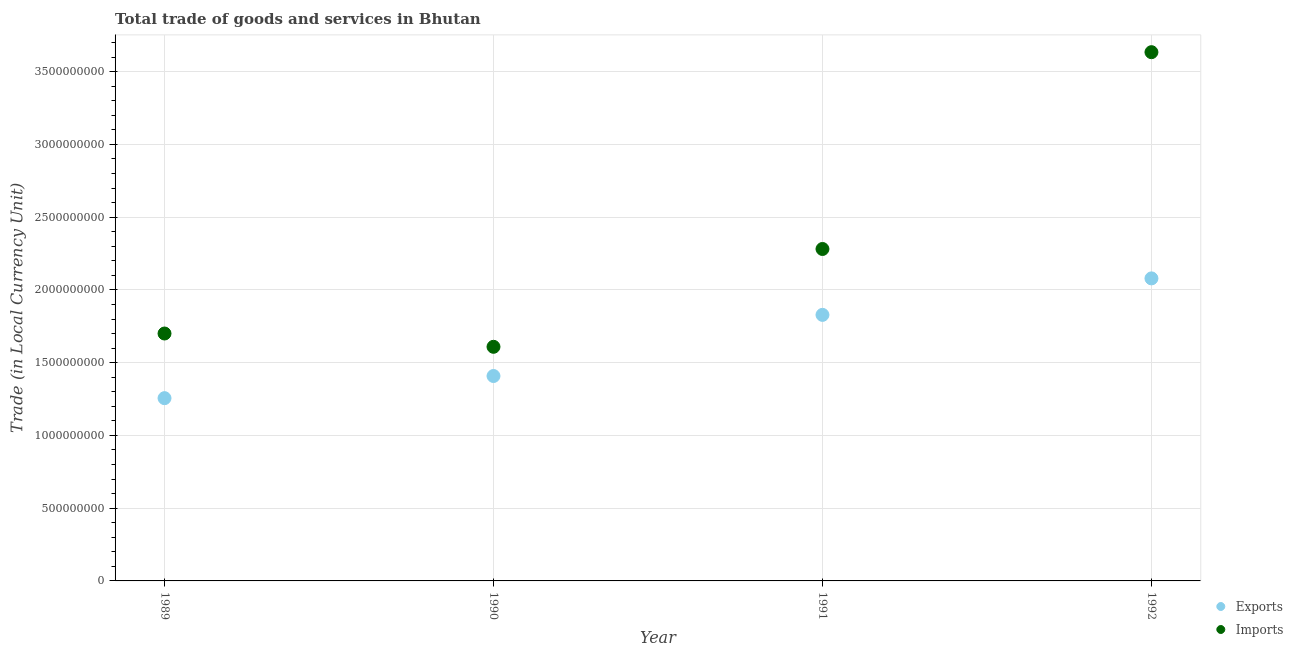Is the number of dotlines equal to the number of legend labels?
Your answer should be very brief. Yes. What is the export of goods and services in 1992?
Offer a terse response. 2.08e+09. Across all years, what is the maximum export of goods and services?
Give a very brief answer. 2.08e+09. Across all years, what is the minimum imports of goods and services?
Make the answer very short. 1.61e+09. In which year was the imports of goods and services maximum?
Your response must be concise. 1992. What is the total export of goods and services in the graph?
Provide a succinct answer. 6.57e+09. What is the difference between the export of goods and services in 1989 and that in 1990?
Keep it short and to the point. -1.52e+08. What is the difference between the export of goods and services in 1991 and the imports of goods and services in 1992?
Give a very brief answer. -1.81e+09. What is the average imports of goods and services per year?
Give a very brief answer. 2.31e+09. In the year 1989, what is the difference between the imports of goods and services and export of goods and services?
Ensure brevity in your answer.  4.44e+08. In how many years, is the imports of goods and services greater than 900000000 LCU?
Your response must be concise. 4. What is the ratio of the imports of goods and services in 1989 to that in 1991?
Offer a very short reply. 0.75. Is the difference between the export of goods and services in 1990 and 1991 greater than the difference between the imports of goods and services in 1990 and 1991?
Your answer should be compact. Yes. What is the difference between the highest and the second highest export of goods and services?
Give a very brief answer. 2.51e+08. What is the difference between the highest and the lowest imports of goods and services?
Offer a terse response. 2.03e+09. Is the sum of the imports of goods and services in 1989 and 1991 greater than the maximum export of goods and services across all years?
Provide a short and direct response. Yes. Is the imports of goods and services strictly less than the export of goods and services over the years?
Ensure brevity in your answer.  No. How many dotlines are there?
Provide a succinct answer. 2. How many years are there in the graph?
Give a very brief answer. 4. What is the difference between two consecutive major ticks on the Y-axis?
Provide a succinct answer. 5.00e+08. Are the values on the major ticks of Y-axis written in scientific E-notation?
Keep it short and to the point. No. Does the graph contain grids?
Provide a succinct answer. Yes. How many legend labels are there?
Your answer should be very brief. 2. What is the title of the graph?
Make the answer very short. Total trade of goods and services in Bhutan. What is the label or title of the X-axis?
Offer a very short reply. Year. What is the label or title of the Y-axis?
Offer a terse response. Trade (in Local Currency Unit). What is the Trade (in Local Currency Unit) of Exports in 1989?
Keep it short and to the point. 1.26e+09. What is the Trade (in Local Currency Unit) of Imports in 1989?
Offer a terse response. 1.70e+09. What is the Trade (in Local Currency Unit) in Exports in 1990?
Offer a very short reply. 1.41e+09. What is the Trade (in Local Currency Unit) of Imports in 1990?
Make the answer very short. 1.61e+09. What is the Trade (in Local Currency Unit) in Exports in 1991?
Your answer should be compact. 1.83e+09. What is the Trade (in Local Currency Unit) of Imports in 1991?
Keep it short and to the point. 2.28e+09. What is the Trade (in Local Currency Unit) in Exports in 1992?
Your answer should be compact. 2.08e+09. What is the Trade (in Local Currency Unit) of Imports in 1992?
Keep it short and to the point. 3.63e+09. Across all years, what is the maximum Trade (in Local Currency Unit) in Exports?
Provide a short and direct response. 2.08e+09. Across all years, what is the maximum Trade (in Local Currency Unit) in Imports?
Your response must be concise. 3.63e+09. Across all years, what is the minimum Trade (in Local Currency Unit) in Exports?
Keep it short and to the point. 1.26e+09. Across all years, what is the minimum Trade (in Local Currency Unit) in Imports?
Provide a succinct answer. 1.61e+09. What is the total Trade (in Local Currency Unit) in Exports in the graph?
Provide a short and direct response. 6.57e+09. What is the total Trade (in Local Currency Unit) of Imports in the graph?
Offer a terse response. 9.22e+09. What is the difference between the Trade (in Local Currency Unit) of Exports in 1989 and that in 1990?
Your response must be concise. -1.52e+08. What is the difference between the Trade (in Local Currency Unit) of Imports in 1989 and that in 1990?
Your answer should be compact. 9.14e+07. What is the difference between the Trade (in Local Currency Unit) in Exports in 1989 and that in 1991?
Your answer should be compact. -5.72e+08. What is the difference between the Trade (in Local Currency Unit) in Imports in 1989 and that in 1991?
Provide a short and direct response. -5.81e+08. What is the difference between the Trade (in Local Currency Unit) of Exports in 1989 and that in 1992?
Keep it short and to the point. -8.23e+08. What is the difference between the Trade (in Local Currency Unit) in Imports in 1989 and that in 1992?
Offer a very short reply. -1.93e+09. What is the difference between the Trade (in Local Currency Unit) in Exports in 1990 and that in 1991?
Keep it short and to the point. -4.20e+08. What is the difference between the Trade (in Local Currency Unit) of Imports in 1990 and that in 1991?
Provide a succinct answer. -6.72e+08. What is the difference between the Trade (in Local Currency Unit) in Exports in 1990 and that in 1992?
Your answer should be very brief. -6.71e+08. What is the difference between the Trade (in Local Currency Unit) in Imports in 1990 and that in 1992?
Offer a terse response. -2.03e+09. What is the difference between the Trade (in Local Currency Unit) in Exports in 1991 and that in 1992?
Offer a terse response. -2.51e+08. What is the difference between the Trade (in Local Currency Unit) of Imports in 1991 and that in 1992?
Keep it short and to the point. -1.35e+09. What is the difference between the Trade (in Local Currency Unit) of Exports in 1989 and the Trade (in Local Currency Unit) of Imports in 1990?
Keep it short and to the point. -3.53e+08. What is the difference between the Trade (in Local Currency Unit) of Exports in 1989 and the Trade (in Local Currency Unit) of Imports in 1991?
Offer a terse response. -1.03e+09. What is the difference between the Trade (in Local Currency Unit) of Exports in 1989 and the Trade (in Local Currency Unit) of Imports in 1992?
Provide a succinct answer. -2.38e+09. What is the difference between the Trade (in Local Currency Unit) of Exports in 1990 and the Trade (in Local Currency Unit) of Imports in 1991?
Ensure brevity in your answer.  -8.73e+08. What is the difference between the Trade (in Local Currency Unit) in Exports in 1990 and the Trade (in Local Currency Unit) in Imports in 1992?
Your response must be concise. -2.23e+09. What is the difference between the Trade (in Local Currency Unit) of Exports in 1991 and the Trade (in Local Currency Unit) of Imports in 1992?
Offer a very short reply. -1.81e+09. What is the average Trade (in Local Currency Unit) in Exports per year?
Give a very brief answer. 1.64e+09. What is the average Trade (in Local Currency Unit) in Imports per year?
Offer a terse response. 2.31e+09. In the year 1989, what is the difference between the Trade (in Local Currency Unit) in Exports and Trade (in Local Currency Unit) in Imports?
Offer a terse response. -4.44e+08. In the year 1990, what is the difference between the Trade (in Local Currency Unit) in Exports and Trade (in Local Currency Unit) in Imports?
Keep it short and to the point. -2.01e+08. In the year 1991, what is the difference between the Trade (in Local Currency Unit) in Exports and Trade (in Local Currency Unit) in Imports?
Offer a very short reply. -4.53e+08. In the year 1992, what is the difference between the Trade (in Local Currency Unit) in Exports and Trade (in Local Currency Unit) in Imports?
Your answer should be compact. -1.55e+09. What is the ratio of the Trade (in Local Currency Unit) of Exports in 1989 to that in 1990?
Your answer should be very brief. 0.89. What is the ratio of the Trade (in Local Currency Unit) in Imports in 1989 to that in 1990?
Offer a very short reply. 1.06. What is the ratio of the Trade (in Local Currency Unit) in Exports in 1989 to that in 1991?
Provide a short and direct response. 0.69. What is the ratio of the Trade (in Local Currency Unit) of Imports in 1989 to that in 1991?
Provide a succinct answer. 0.75. What is the ratio of the Trade (in Local Currency Unit) of Exports in 1989 to that in 1992?
Make the answer very short. 0.6. What is the ratio of the Trade (in Local Currency Unit) in Imports in 1989 to that in 1992?
Ensure brevity in your answer.  0.47. What is the ratio of the Trade (in Local Currency Unit) in Exports in 1990 to that in 1991?
Ensure brevity in your answer.  0.77. What is the ratio of the Trade (in Local Currency Unit) of Imports in 1990 to that in 1991?
Your response must be concise. 0.71. What is the ratio of the Trade (in Local Currency Unit) in Exports in 1990 to that in 1992?
Your answer should be very brief. 0.68. What is the ratio of the Trade (in Local Currency Unit) in Imports in 1990 to that in 1992?
Your answer should be very brief. 0.44. What is the ratio of the Trade (in Local Currency Unit) of Exports in 1991 to that in 1992?
Offer a terse response. 0.88. What is the ratio of the Trade (in Local Currency Unit) in Imports in 1991 to that in 1992?
Ensure brevity in your answer.  0.63. What is the difference between the highest and the second highest Trade (in Local Currency Unit) in Exports?
Give a very brief answer. 2.51e+08. What is the difference between the highest and the second highest Trade (in Local Currency Unit) in Imports?
Offer a terse response. 1.35e+09. What is the difference between the highest and the lowest Trade (in Local Currency Unit) of Exports?
Provide a succinct answer. 8.23e+08. What is the difference between the highest and the lowest Trade (in Local Currency Unit) of Imports?
Provide a succinct answer. 2.03e+09. 